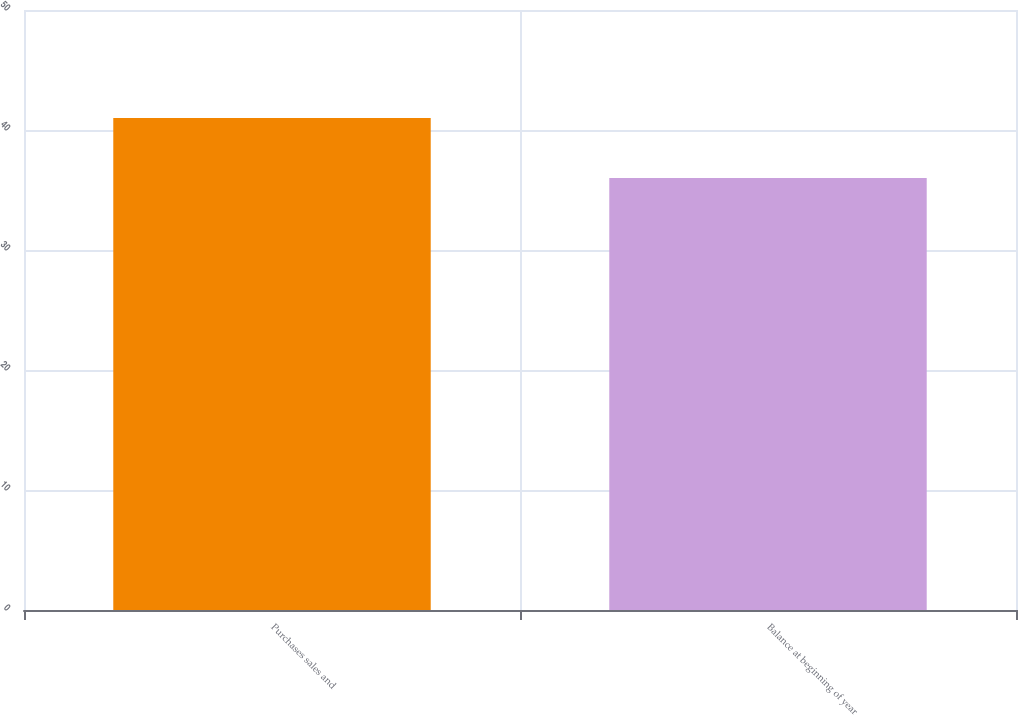Convert chart. <chart><loc_0><loc_0><loc_500><loc_500><bar_chart><fcel>Purchases sales and<fcel>Balance at beginning of year<nl><fcel>41<fcel>36<nl></chart> 